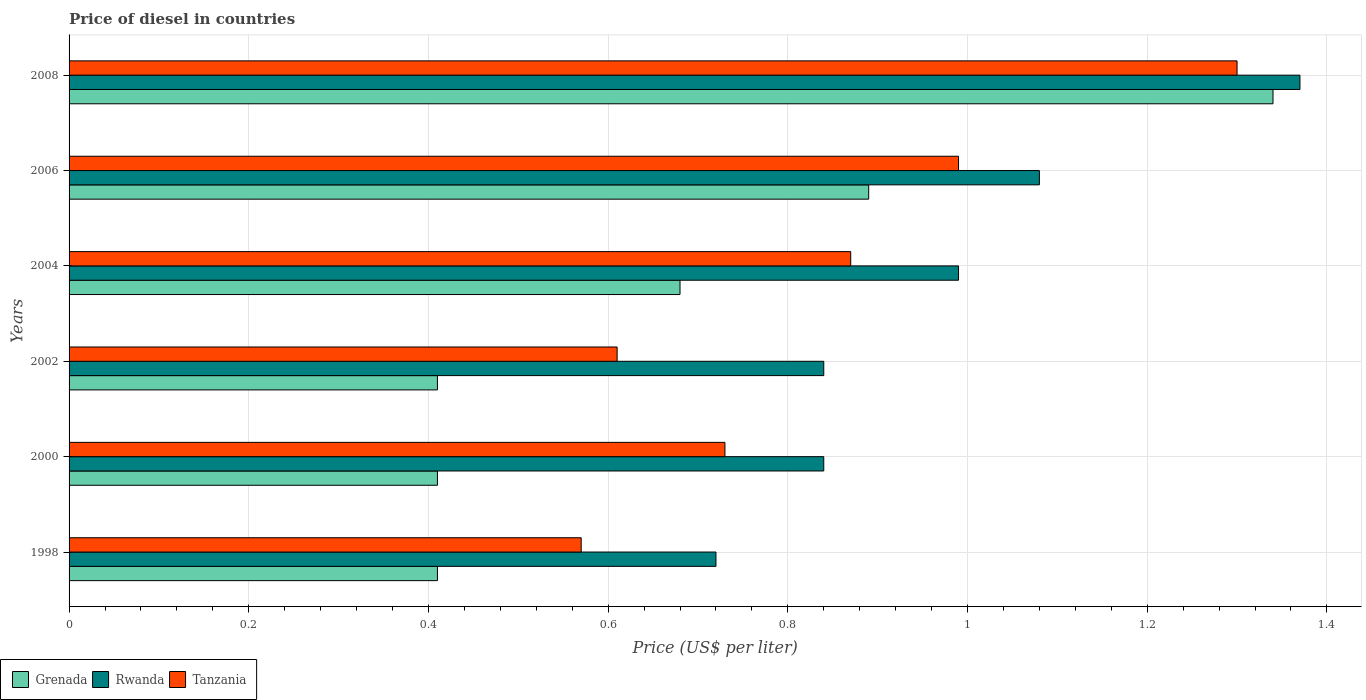How many different coloured bars are there?
Your answer should be compact. 3. How many groups of bars are there?
Give a very brief answer. 6. Are the number of bars on each tick of the Y-axis equal?
Give a very brief answer. Yes. What is the price of diesel in Rwanda in 1998?
Your answer should be compact. 0.72. Across all years, what is the maximum price of diesel in Rwanda?
Your response must be concise. 1.37. Across all years, what is the minimum price of diesel in Grenada?
Your answer should be very brief. 0.41. What is the total price of diesel in Tanzania in the graph?
Make the answer very short. 5.07. What is the difference between the price of diesel in Grenada in 2006 and that in 2008?
Your answer should be compact. -0.45. What is the difference between the price of diesel in Grenada in 2004 and the price of diesel in Rwanda in 2000?
Your response must be concise. -0.16. What is the average price of diesel in Rwanda per year?
Make the answer very short. 0.97. In the year 2004, what is the difference between the price of diesel in Rwanda and price of diesel in Grenada?
Provide a short and direct response. 0.31. What is the ratio of the price of diesel in Grenada in 2004 to that in 2006?
Give a very brief answer. 0.76. Is the difference between the price of diesel in Rwanda in 1998 and 2004 greater than the difference between the price of diesel in Grenada in 1998 and 2004?
Keep it short and to the point. Yes. What is the difference between the highest and the second highest price of diesel in Tanzania?
Your response must be concise. 0.31. What is the difference between the highest and the lowest price of diesel in Tanzania?
Your response must be concise. 0.73. Is the sum of the price of diesel in Rwanda in 1998 and 2000 greater than the maximum price of diesel in Tanzania across all years?
Ensure brevity in your answer.  Yes. What does the 3rd bar from the top in 1998 represents?
Keep it short and to the point. Grenada. What does the 3rd bar from the bottom in 2000 represents?
Provide a short and direct response. Tanzania. How many years are there in the graph?
Your answer should be compact. 6. How are the legend labels stacked?
Provide a succinct answer. Horizontal. What is the title of the graph?
Make the answer very short. Price of diesel in countries. What is the label or title of the X-axis?
Ensure brevity in your answer.  Price (US$ per liter). What is the Price (US$ per liter) of Grenada in 1998?
Offer a terse response. 0.41. What is the Price (US$ per liter) in Rwanda in 1998?
Make the answer very short. 0.72. What is the Price (US$ per liter) of Tanzania in 1998?
Provide a short and direct response. 0.57. What is the Price (US$ per liter) of Grenada in 2000?
Ensure brevity in your answer.  0.41. What is the Price (US$ per liter) of Rwanda in 2000?
Provide a succinct answer. 0.84. What is the Price (US$ per liter) of Tanzania in 2000?
Make the answer very short. 0.73. What is the Price (US$ per liter) in Grenada in 2002?
Make the answer very short. 0.41. What is the Price (US$ per liter) in Rwanda in 2002?
Offer a terse response. 0.84. What is the Price (US$ per liter) in Tanzania in 2002?
Offer a very short reply. 0.61. What is the Price (US$ per liter) of Grenada in 2004?
Offer a terse response. 0.68. What is the Price (US$ per liter) in Tanzania in 2004?
Offer a terse response. 0.87. What is the Price (US$ per liter) in Grenada in 2006?
Keep it short and to the point. 0.89. What is the Price (US$ per liter) of Tanzania in 2006?
Your answer should be compact. 0.99. What is the Price (US$ per liter) of Grenada in 2008?
Your answer should be compact. 1.34. What is the Price (US$ per liter) in Rwanda in 2008?
Keep it short and to the point. 1.37. Across all years, what is the maximum Price (US$ per liter) of Grenada?
Keep it short and to the point. 1.34. Across all years, what is the maximum Price (US$ per liter) in Rwanda?
Your answer should be compact. 1.37. Across all years, what is the minimum Price (US$ per liter) in Grenada?
Offer a terse response. 0.41. Across all years, what is the minimum Price (US$ per liter) of Rwanda?
Make the answer very short. 0.72. Across all years, what is the minimum Price (US$ per liter) of Tanzania?
Offer a very short reply. 0.57. What is the total Price (US$ per liter) of Grenada in the graph?
Your answer should be very brief. 4.14. What is the total Price (US$ per liter) in Rwanda in the graph?
Your response must be concise. 5.84. What is the total Price (US$ per liter) in Tanzania in the graph?
Offer a very short reply. 5.07. What is the difference between the Price (US$ per liter) in Grenada in 1998 and that in 2000?
Ensure brevity in your answer.  0. What is the difference between the Price (US$ per liter) in Rwanda in 1998 and that in 2000?
Make the answer very short. -0.12. What is the difference between the Price (US$ per liter) of Tanzania in 1998 and that in 2000?
Make the answer very short. -0.16. What is the difference between the Price (US$ per liter) in Rwanda in 1998 and that in 2002?
Ensure brevity in your answer.  -0.12. What is the difference between the Price (US$ per liter) in Tanzania in 1998 and that in 2002?
Your answer should be very brief. -0.04. What is the difference between the Price (US$ per liter) of Grenada in 1998 and that in 2004?
Provide a succinct answer. -0.27. What is the difference between the Price (US$ per liter) of Rwanda in 1998 and that in 2004?
Make the answer very short. -0.27. What is the difference between the Price (US$ per liter) in Tanzania in 1998 and that in 2004?
Provide a succinct answer. -0.3. What is the difference between the Price (US$ per liter) of Grenada in 1998 and that in 2006?
Your answer should be very brief. -0.48. What is the difference between the Price (US$ per liter) of Rwanda in 1998 and that in 2006?
Your answer should be compact. -0.36. What is the difference between the Price (US$ per liter) of Tanzania in 1998 and that in 2006?
Your response must be concise. -0.42. What is the difference between the Price (US$ per liter) in Grenada in 1998 and that in 2008?
Offer a terse response. -0.93. What is the difference between the Price (US$ per liter) of Rwanda in 1998 and that in 2008?
Ensure brevity in your answer.  -0.65. What is the difference between the Price (US$ per liter) in Tanzania in 1998 and that in 2008?
Give a very brief answer. -0.73. What is the difference between the Price (US$ per liter) of Rwanda in 2000 and that in 2002?
Give a very brief answer. 0. What is the difference between the Price (US$ per liter) in Tanzania in 2000 and that in 2002?
Offer a terse response. 0.12. What is the difference between the Price (US$ per liter) of Grenada in 2000 and that in 2004?
Make the answer very short. -0.27. What is the difference between the Price (US$ per liter) in Rwanda in 2000 and that in 2004?
Keep it short and to the point. -0.15. What is the difference between the Price (US$ per liter) in Tanzania in 2000 and that in 2004?
Provide a succinct answer. -0.14. What is the difference between the Price (US$ per liter) in Grenada in 2000 and that in 2006?
Keep it short and to the point. -0.48. What is the difference between the Price (US$ per liter) in Rwanda in 2000 and that in 2006?
Offer a terse response. -0.24. What is the difference between the Price (US$ per liter) of Tanzania in 2000 and that in 2006?
Make the answer very short. -0.26. What is the difference between the Price (US$ per liter) in Grenada in 2000 and that in 2008?
Your response must be concise. -0.93. What is the difference between the Price (US$ per liter) in Rwanda in 2000 and that in 2008?
Ensure brevity in your answer.  -0.53. What is the difference between the Price (US$ per liter) of Tanzania in 2000 and that in 2008?
Give a very brief answer. -0.57. What is the difference between the Price (US$ per liter) in Grenada in 2002 and that in 2004?
Offer a terse response. -0.27. What is the difference between the Price (US$ per liter) of Tanzania in 2002 and that in 2004?
Provide a short and direct response. -0.26. What is the difference between the Price (US$ per liter) of Grenada in 2002 and that in 2006?
Offer a very short reply. -0.48. What is the difference between the Price (US$ per liter) in Rwanda in 2002 and that in 2006?
Offer a very short reply. -0.24. What is the difference between the Price (US$ per liter) in Tanzania in 2002 and that in 2006?
Provide a short and direct response. -0.38. What is the difference between the Price (US$ per liter) in Grenada in 2002 and that in 2008?
Your answer should be compact. -0.93. What is the difference between the Price (US$ per liter) in Rwanda in 2002 and that in 2008?
Provide a short and direct response. -0.53. What is the difference between the Price (US$ per liter) in Tanzania in 2002 and that in 2008?
Your answer should be very brief. -0.69. What is the difference between the Price (US$ per liter) in Grenada in 2004 and that in 2006?
Provide a short and direct response. -0.21. What is the difference between the Price (US$ per liter) in Rwanda in 2004 and that in 2006?
Your answer should be very brief. -0.09. What is the difference between the Price (US$ per liter) of Tanzania in 2004 and that in 2006?
Offer a terse response. -0.12. What is the difference between the Price (US$ per liter) of Grenada in 2004 and that in 2008?
Keep it short and to the point. -0.66. What is the difference between the Price (US$ per liter) of Rwanda in 2004 and that in 2008?
Make the answer very short. -0.38. What is the difference between the Price (US$ per liter) in Tanzania in 2004 and that in 2008?
Give a very brief answer. -0.43. What is the difference between the Price (US$ per liter) of Grenada in 2006 and that in 2008?
Keep it short and to the point. -0.45. What is the difference between the Price (US$ per liter) in Rwanda in 2006 and that in 2008?
Make the answer very short. -0.29. What is the difference between the Price (US$ per liter) in Tanzania in 2006 and that in 2008?
Make the answer very short. -0.31. What is the difference between the Price (US$ per liter) of Grenada in 1998 and the Price (US$ per liter) of Rwanda in 2000?
Your response must be concise. -0.43. What is the difference between the Price (US$ per liter) of Grenada in 1998 and the Price (US$ per liter) of Tanzania in 2000?
Your answer should be very brief. -0.32. What is the difference between the Price (US$ per liter) of Rwanda in 1998 and the Price (US$ per liter) of Tanzania in 2000?
Provide a short and direct response. -0.01. What is the difference between the Price (US$ per liter) of Grenada in 1998 and the Price (US$ per liter) of Rwanda in 2002?
Provide a succinct answer. -0.43. What is the difference between the Price (US$ per liter) of Rwanda in 1998 and the Price (US$ per liter) of Tanzania in 2002?
Offer a terse response. 0.11. What is the difference between the Price (US$ per liter) of Grenada in 1998 and the Price (US$ per liter) of Rwanda in 2004?
Give a very brief answer. -0.58. What is the difference between the Price (US$ per liter) in Grenada in 1998 and the Price (US$ per liter) in Tanzania in 2004?
Keep it short and to the point. -0.46. What is the difference between the Price (US$ per liter) of Rwanda in 1998 and the Price (US$ per liter) of Tanzania in 2004?
Provide a succinct answer. -0.15. What is the difference between the Price (US$ per liter) in Grenada in 1998 and the Price (US$ per liter) in Rwanda in 2006?
Offer a terse response. -0.67. What is the difference between the Price (US$ per liter) in Grenada in 1998 and the Price (US$ per liter) in Tanzania in 2006?
Provide a short and direct response. -0.58. What is the difference between the Price (US$ per liter) in Rwanda in 1998 and the Price (US$ per liter) in Tanzania in 2006?
Keep it short and to the point. -0.27. What is the difference between the Price (US$ per liter) of Grenada in 1998 and the Price (US$ per liter) of Rwanda in 2008?
Provide a succinct answer. -0.96. What is the difference between the Price (US$ per liter) of Grenada in 1998 and the Price (US$ per liter) of Tanzania in 2008?
Provide a succinct answer. -0.89. What is the difference between the Price (US$ per liter) of Rwanda in 1998 and the Price (US$ per liter) of Tanzania in 2008?
Give a very brief answer. -0.58. What is the difference between the Price (US$ per liter) of Grenada in 2000 and the Price (US$ per liter) of Rwanda in 2002?
Give a very brief answer. -0.43. What is the difference between the Price (US$ per liter) of Grenada in 2000 and the Price (US$ per liter) of Tanzania in 2002?
Provide a short and direct response. -0.2. What is the difference between the Price (US$ per liter) in Rwanda in 2000 and the Price (US$ per liter) in Tanzania in 2002?
Make the answer very short. 0.23. What is the difference between the Price (US$ per liter) of Grenada in 2000 and the Price (US$ per liter) of Rwanda in 2004?
Give a very brief answer. -0.58. What is the difference between the Price (US$ per liter) of Grenada in 2000 and the Price (US$ per liter) of Tanzania in 2004?
Provide a short and direct response. -0.46. What is the difference between the Price (US$ per liter) of Rwanda in 2000 and the Price (US$ per liter) of Tanzania in 2004?
Keep it short and to the point. -0.03. What is the difference between the Price (US$ per liter) of Grenada in 2000 and the Price (US$ per liter) of Rwanda in 2006?
Offer a very short reply. -0.67. What is the difference between the Price (US$ per liter) of Grenada in 2000 and the Price (US$ per liter) of Tanzania in 2006?
Provide a succinct answer. -0.58. What is the difference between the Price (US$ per liter) in Grenada in 2000 and the Price (US$ per liter) in Rwanda in 2008?
Your answer should be compact. -0.96. What is the difference between the Price (US$ per liter) of Grenada in 2000 and the Price (US$ per liter) of Tanzania in 2008?
Offer a terse response. -0.89. What is the difference between the Price (US$ per liter) in Rwanda in 2000 and the Price (US$ per liter) in Tanzania in 2008?
Your answer should be compact. -0.46. What is the difference between the Price (US$ per liter) in Grenada in 2002 and the Price (US$ per liter) in Rwanda in 2004?
Provide a succinct answer. -0.58. What is the difference between the Price (US$ per liter) in Grenada in 2002 and the Price (US$ per liter) in Tanzania in 2004?
Provide a succinct answer. -0.46. What is the difference between the Price (US$ per liter) in Rwanda in 2002 and the Price (US$ per liter) in Tanzania in 2004?
Give a very brief answer. -0.03. What is the difference between the Price (US$ per liter) of Grenada in 2002 and the Price (US$ per liter) of Rwanda in 2006?
Offer a terse response. -0.67. What is the difference between the Price (US$ per liter) in Grenada in 2002 and the Price (US$ per liter) in Tanzania in 2006?
Offer a terse response. -0.58. What is the difference between the Price (US$ per liter) in Grenada in 2002 and the Price (US$ per liter) in Rwanda in 2008?
Make the answer very short. -0.96. What is the difference between the Price (US$ per liter) of Grenada in 2002 and the Price (US$ per liter) of Tanzania in 2008?
Keep it short and to the point. -0.89. What is the difference between the Price (US$ per liter) of Rwanda in 2002 and the Price (US$ per liter) of Tanzania in 2008?
Provide a short and direct response. -0.46. What is the difference between the Price (US$ per liter) in Grenada in 2004 and the Price (US$ per liter) in Rwanda in 2006?
Your answer should be very brief. -0.4. What is the difference between the Price (US$ per liter) in Grenada in 2004 and the Price (US$ per liter) in Tanzania in 2006?
Offer a terse response. -0.31. What is the difference between the Price (US$ per liter) of Grenada in 2004 and the Price (US$ per liter) of Rwanda in 2008?
Ensure brevity in your answer.  -0.69. What is the difference between the Price (US$ per liter) in Grenada in 2004 and the Price (US$ per liter) in Tanzania in 2008?
Offer a terse response. -0.62. What is the difference between the Price (US$ per liter) in Rwanda in 2004 and the Price (US$ per liter) in Tanzania in 2008?
Provide a succinct answer. -0.31. What is the difference between the Price (US$ per liter) in Grenada in 2006 and the Price (US$ per liter) in Rwanda in 2008?
Provide a succinct answer. -0.48. What is the difference between the Price (US$ per liter) of Grenada in 2006 and the Price (US$ per liter) of Tanzania in 2008?
Your answer should be compact. -0.41. What is the difference between the Price (US$ per liter) of Rwanda in 2006 and the Price (US$ per liter) of Tanzania in 2008?
Provide a succinct answer. -0.22. What is the average Price (US$ per liter) in Grenada per year?
Provide a succinct answer. 0.69. What is the average Price (US$ per liter) of Rwanda per year?
Provide a succinct answer. 0.97. What is the average Price (US$ per liter) of Tanzania per year?
Ensure brevity in your answer.  0.84. In the year 1998, what is the difference between the Price (US$ per liter) in Grenada and Price (US$ per liter) in Rwanda?
Offer a terse response. -0.31. In the year 1998, what is the difference between the Price (US$ per liter) in Grenada and Price (US$ per liter) in Tanzania?
Provide a succinct answer. -0.16. In the year 2000, what is the difference between the Price (US$ per liter) of Grenada and Price (US$ per liter) of Rwanda?
Ensure brevity in your answer.  -0.43. In the year 2000, what is the difference between the Price (US$ per liter) of Grenada and Price (US$ per liter) of Tanzania?
Keep it short and to the point. -0.32. In the year 2000, what is the difference between the Price (US$ per liter) of Rwanda and Price (US$ per liter) of Tanzania?
Give a very brief answer. 0.11. In the year 2002, what is the difference between the Price (US$ per liter) of Grenada and Price (US$ per liter) of Rwanda?
Provide a succinct answer. -0.43. In the year 2002, what is the difference between the Price (US$ per liter) of Rwanda and Price (US$ per liter) of Tanzania?
Keep it short and to the point. 0.23. In the year 2004, what is the difference between the Price (US$ per liter) of Grenada and Price (US$ per liter) of Rwanda?
Your answer should be very brief. -0.31. In the year 2004, what is the difference between the Price (US$ per liter) in Grenada and Price (US$ per liter) in Tanzania?
Offer a very short reply. -0.19. In the year 2004, what is the difference between the Price (US$ per liter) in Rwanda and Price (US$ per liter) in Tanzania?
Give a very brief answer. 0.12. In the year 2006, what is the difference between the Price (US$ per liter) of Grenada and Price (US$ per liter) of Rwanda?
Your response must be concise. -0.19. In the year 2006, what is the difference between the Price (US$ per liter) in Grenada and Price (US$ per liter) in Tanzania?
Provide a short and direct response. -0.1. In the year 2006, what is the difference between the Price (US$ per liter) in Rwanda and Price (US$ per liter) in Tanzania?
Offer a very short reply. 0.09. In the year 2008, what is the difference between the Price (US$ per liter) in Grenada and Price (US$ per liter) in Rwanda?
Provide a short and direct response. -0.03. In the year 2008, what is the difference between the Price (US$ per liter) in Grenada and Price (US$ per liter) in Tanzania?
Your response must be concise. 0.04. In the year 2008, what is the difference between the Price (US$ per liter) in Rwanda and Price (US$ per liter) in Tanzania?
Your answer should be compact. 0.07. What is the ratio of the Price (US$ per liter) in Grenada in 1998 to that in 2000?
Give a very brief answer. 1. What is the ratio of the Price (US$ per liter) of Rwanda in 1998 to that in 2000?
Make the answer very short. 0.86. What is the ratio of the Price (US$ per liter) in Tanzania in 1998 to that in 2000?
Give a very brief answer. 0.78. What is the ratio of the Price (US$ per liter) in Tanzania in 1998 to that in 2002?
Keep it short and to the point. 0.93. What is the ratio of the Price (US$ per liter) of Grenada in 1998 to that in 2004?
Make the answer very short. 0.6. What is the ratio of the Price (US$ per liter) in Rwanda in 1998 to that in 2004?
Offer a very short reply. 0.73. What is the ratio of the Price (US$ per liter) in Tanzania in 1998 to that in 2004?
Your response must be concise. 0.66. What is the ratio of the Price (US$ per liter) of Grenada in 1998 to that in 2006?
Provide a short and direct response. 0.46. What is the ratio of the Price (US$ per liter) in Tanzania in 1998 to that in 2006?
Keep it short and to the point. 0.58. What is the ratio of the Price (US$ per liter) in Grenada in 1998 to that in 2008?
Your answer should be compact. 0.31. What is the ratio of the Price (US$ per liter) of Rwanda in 1998 to that in 2008?
Give a very brief answer. 0.53. What is the ratio of the Price (US$ per liter) in Tanzania in 1998 to that in 2008?
Keep it short and to the point. 0.44. What is the ratio of the Price (US$ per liter) of Grenada in 2000 to that in 2002?
Give a very brief answer. 1. What is the ratio of the Price (US$ per liter) in Rwanda in 2000 to that in 2002?
Ensure brevity in your answer.  1. What is the ratio of the Price (US$ per liter) of Tanzania in 2000 to that in 2002?
Ensure brevity in your answer.  1.2. What is the ratio of the Price (US$ per liter) of Grenada in 2000 to that in 2004?
Provide a short and direct response. 0.6. What is the ratio of the Price (US$ per liter) of Rwanda in 2000 to that in 2004?
Make the answer very short. 0.85. What is the ratio of the Price (US$ per liter) of Tanzania in 2000 to that in 2004?
Your response must be concise. 0.84. What is the ratio of the Price (US$ per liter) of Grenada in 2000 to that in 2006?
Offer a very short reply. 0.46. What is the ratio of the Price (US$ per liter) in Rwanda in 2000 to that in 2006?
Offer a very short reply. 0.78. What is the ratio of the Price (US$ per liter) of Tanzania in 2000 to that in 2006?
Your response must be concise. 0.74. What is the ratio of the Price (US$ per liter) in Grenada in 2000 to that in 2008?
Ensure brevity in your answer.  0.31. What is the ratio of the Price (US$ per liter) in Rwanda in 2000 to that in 2008?
Keep it short and to the point. 0.61. What is the ratio of the Price (US$ per liter) in Tanzania in 2000 to that in 2008?
Give a very brief answer. 0.56. What is the ratio of the Price (US$ per liter) in Grenada in 2002 to that in 2004?
Ensure brevity in your answer.  0.6. What is the ratio of the Price (US$ per liter) of Rwanda in 2002 to that in 2004?
Provide a succinct answer. 0.85. What is the ratio of the Price (US$ per liter) of Tanzania in 2002 to that in 2004?
Offer a terse response. 0.7. What is the ratio of the Price (US$ per liter) in Grenada in 2002 to that in 2006?
Offer a very short reply. 0.46. What is the ratio of the Price (US$ per liter) in Rwanda in 2002 to that in 2006?
Make the answer very short. 0.78. What is the ratio of the Price (US$ per liter) of Tanzania in 2002 to that in 2006?
Your answer should be very brief. 0.62. What is the ratio of the Price (US$ per liter) of Grenada in 2002 to that in 2008?
Ensure brevity in your answer.  0.31. What is the ratio of the Price (US$ per liter) in Rwanda in 2002 to that in 2008?
Your answer should be very brief. 0.61. What is the ratio of the Price (US$ per liter) of Tanzania in 2002 to that in 2008?
Your answer should be compact. 0.47. What is the ratio of the Price (US$ per liter) in Grenada in 2004 to that in 2006?
Ensure brevity in your answer.  0.76. What is the ratio of the Price (US$ per liter) in Tanzania in 2004 to that in 2006?
Offer a very short reply. 0.88. What is the ratio of the Price (US$ per liter) of Grenada in 2004 to that in 2008?
Your answer should be compact. 0.51. What is the ratio of the Price (US$ per liter) in Rwanda in 2004 to that in 2008?
Keep it short and to the point. 0.72. What is the ratio of the Price (US$ per liter) in Tanzania in 2004 to that in 2008?
Offer a very short reply. 0.67. What is the ratio of the Price (US$ per liter) in Grenada in 2006 to that in 2008?
Your response must be concise. 0.66. What is the ratio of the Price (US$ per liter) in Rwanda in 2006 to that in 2008?
Offer a very short reply. 0.79. What is the ratio of the Price (US$ per liter) of Tanzania in 2006 to that in 2008?
Make the answer very short. 0.76. What is the difference between the highest and the second highest Price (US$ per liter) of Grenada?
Your answer should be very brief. 0.45. What is the difference between the highest and the second highest Price (US$ per liter) of Rwanda?
Give a very brief answer. 0.29. What is the difference between the highest and the second highest Price (US$ per liter) in Tanzania?
Offer a very short reply. 0.31. What is the difference between the highest and the lowest Price (US$ per liter) of Grenada?
Your response must be concise. 0.93. What is the difference between the highest and the lowest Price (US$ per liter) in Rwanda?
Your response must be concise. 0.65. What is the difference between the highest and the lowest Price (US$ per liter) in Tanzania?
Your answer should be very brief. 0.73. 